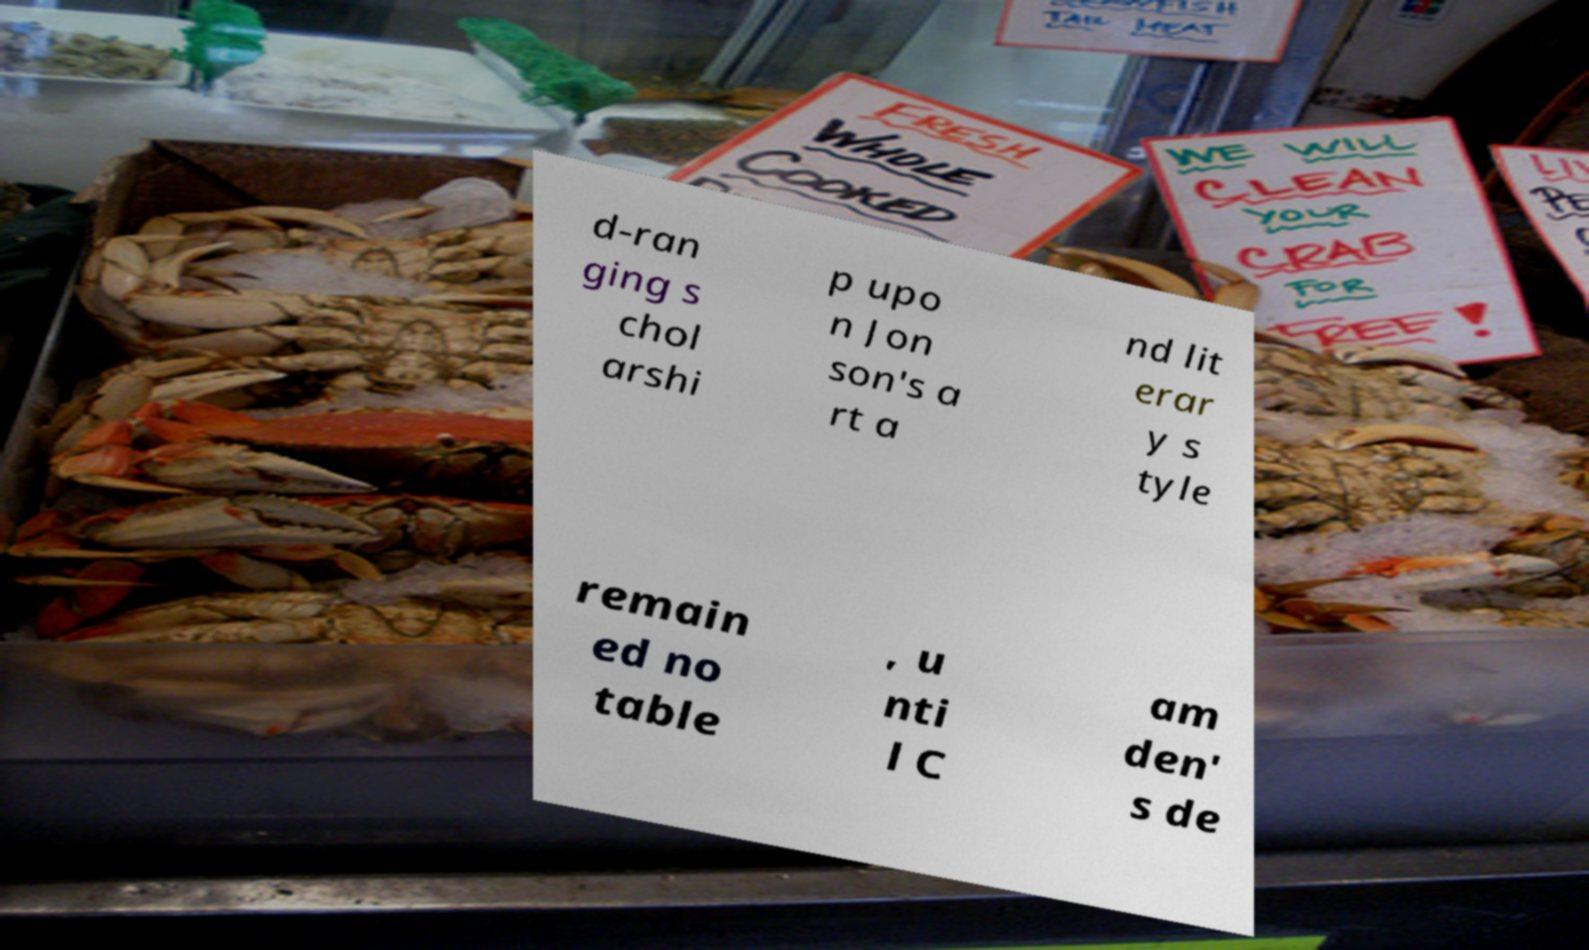Can you read and provide the text displayed in the image?This photo seems to have some interesting text. Can you extract and type it out for me? d-ran ging s chol arshi p upo n Jon son's a rt a nd lit erar y s tyle remain ed no table , u nti l C am den' s de 